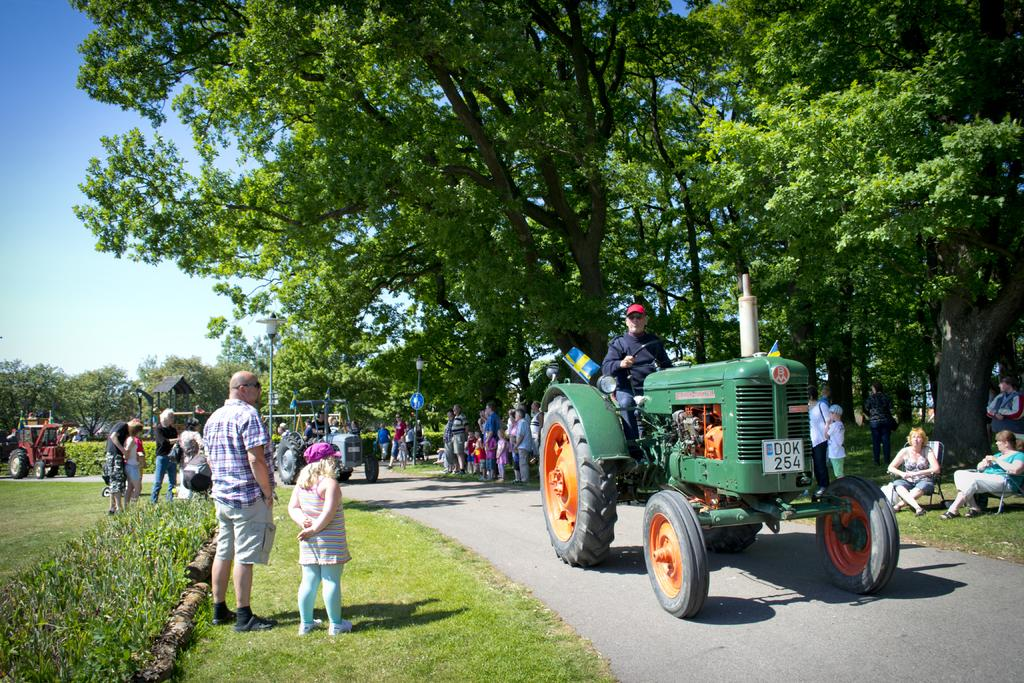What can be seen in the image involving people? There are people standing in the image. What type of pathway is present in the image? There is a road in the image. What natural elements are visible in the image? There are trees and plants in the image. What man-made structures can be seen in the image? There are poles in the image. What is the condition of the sky in the image? The sky is clear in the image. What type of garden can be seen in the image? There is no garden present in the image. What range of activities are the people participating in during the week? The image does not provide information about the people's activities or the time frame, so it cannot be determined from the image. 